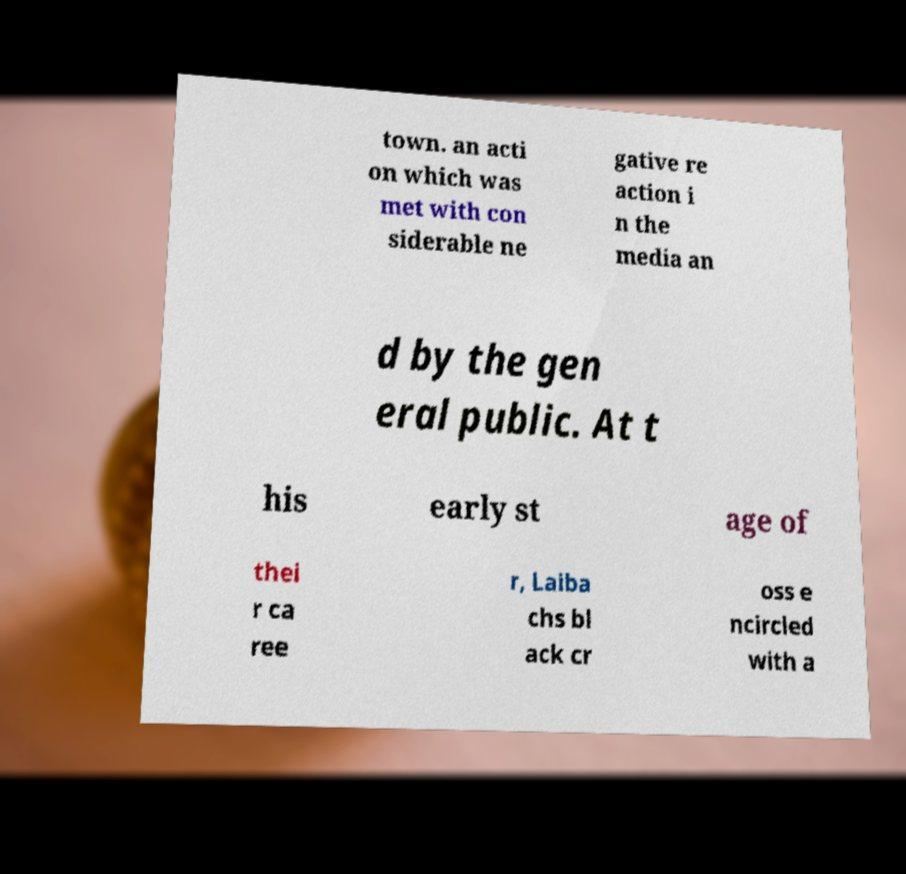Please read and relay the text visible in this image. What does it say? town. an acti on which was met with con siderable ne gative re action i n the media an d by the gen eral public. At t his early st age of thei r ca ree r, Laiba chs bl ack cr oss e ncircled with a 